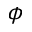Convert formula to latex. <formula><loc_0><loc_0><loc_500><loc_500>\phi</formula> 